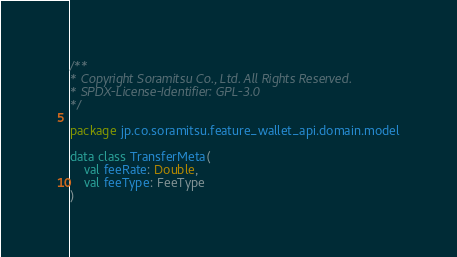<code> <loc_0><loc_0><loc_500><loc_500><_Kotlin_>/**
* Copyright Soramitsu Co., Ltd. All Rights Reserved.
* SPDX-License-Identifier: GPL-3.0
*/

package jp.co.soramitsu.feature_wallet_api.domain.model

data class TransferMeta(
    val feeRate: Double,
    val feeType: FeeType
)</code> 